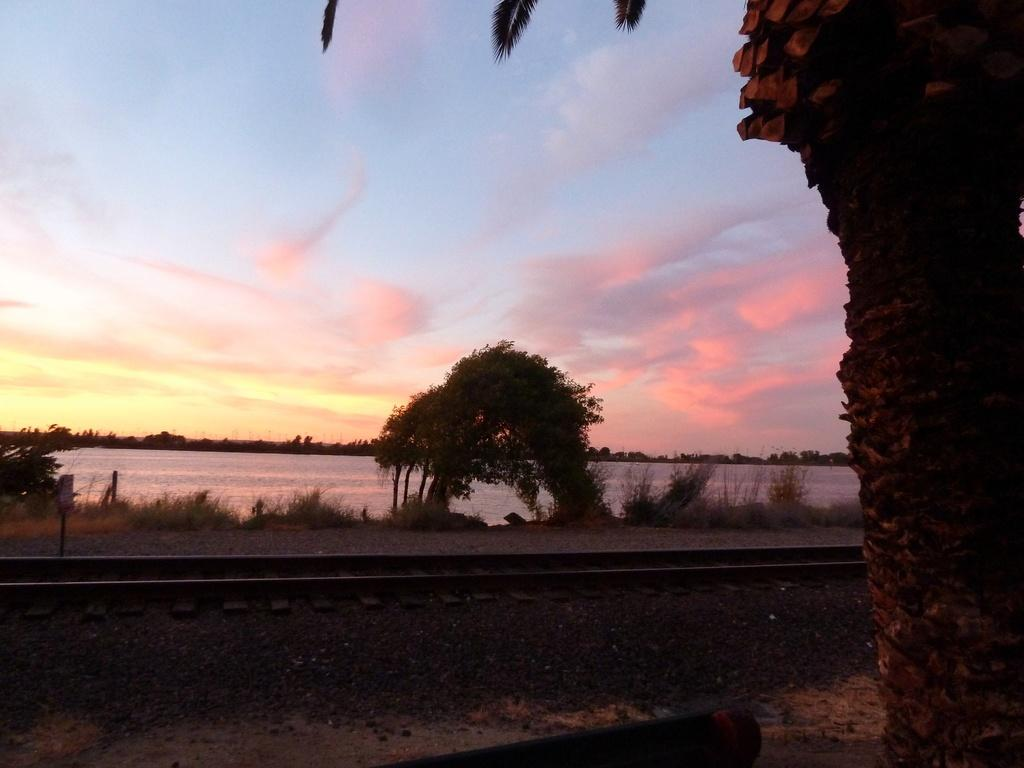What type of natural elements can be seen in the image? There are trees and plants visible in the image. What man-made objects can be seen in the image? There is a board and a rod visible in the image. What type of transportation infrastructure is present in the image? There are train tracks visible in the image. What is the condition of the sky in the image? The sky appears to be cloudy in the image. What else can be seen in the image besides the mentioned elements? There are unspecified objects in the image. What type of salt can be seen on the train tracks in the image? There is no salt visible on the train tracks in the image. What type of grass is growing near the trees in the image? There is no grass visible near the trees in the image. 